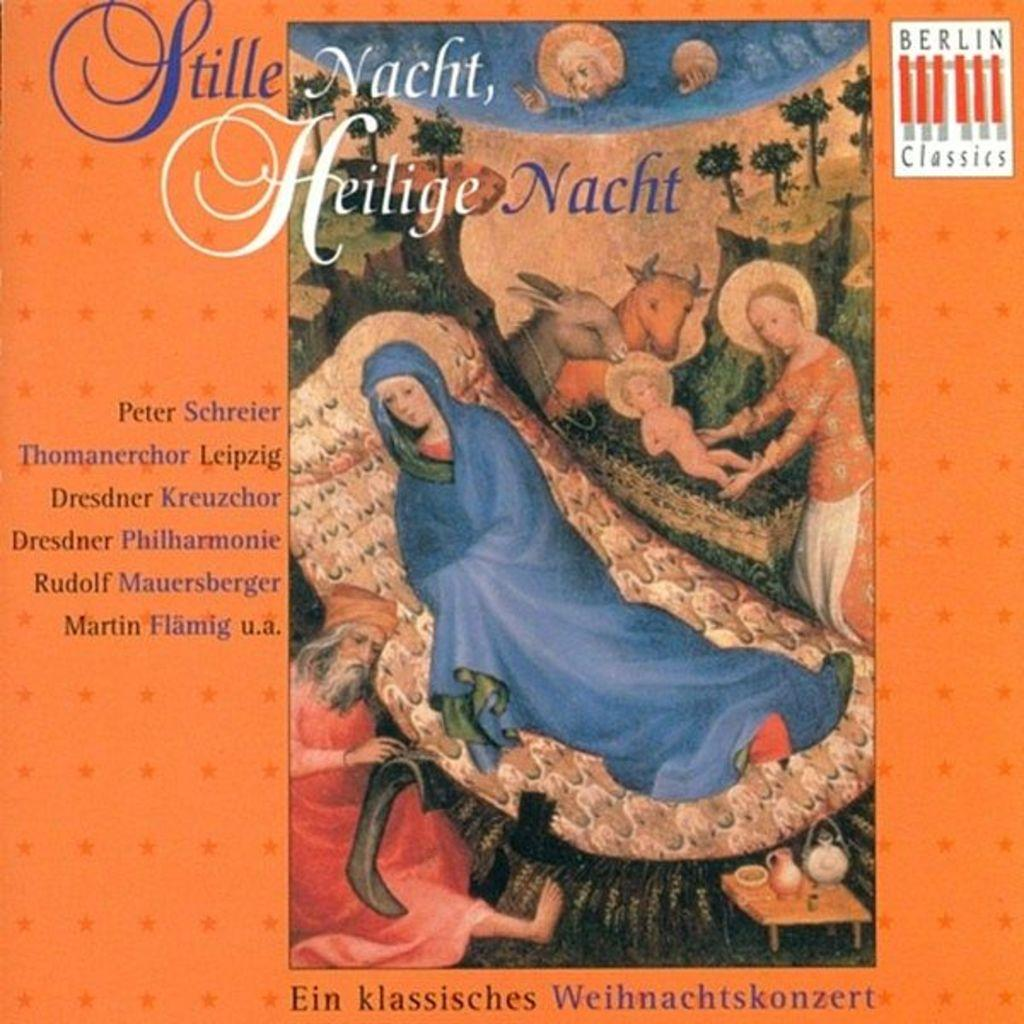Provide a one-sentence caption for the provided image. A foreign poster for something called Stille Nacht, by Peter Schreier. 